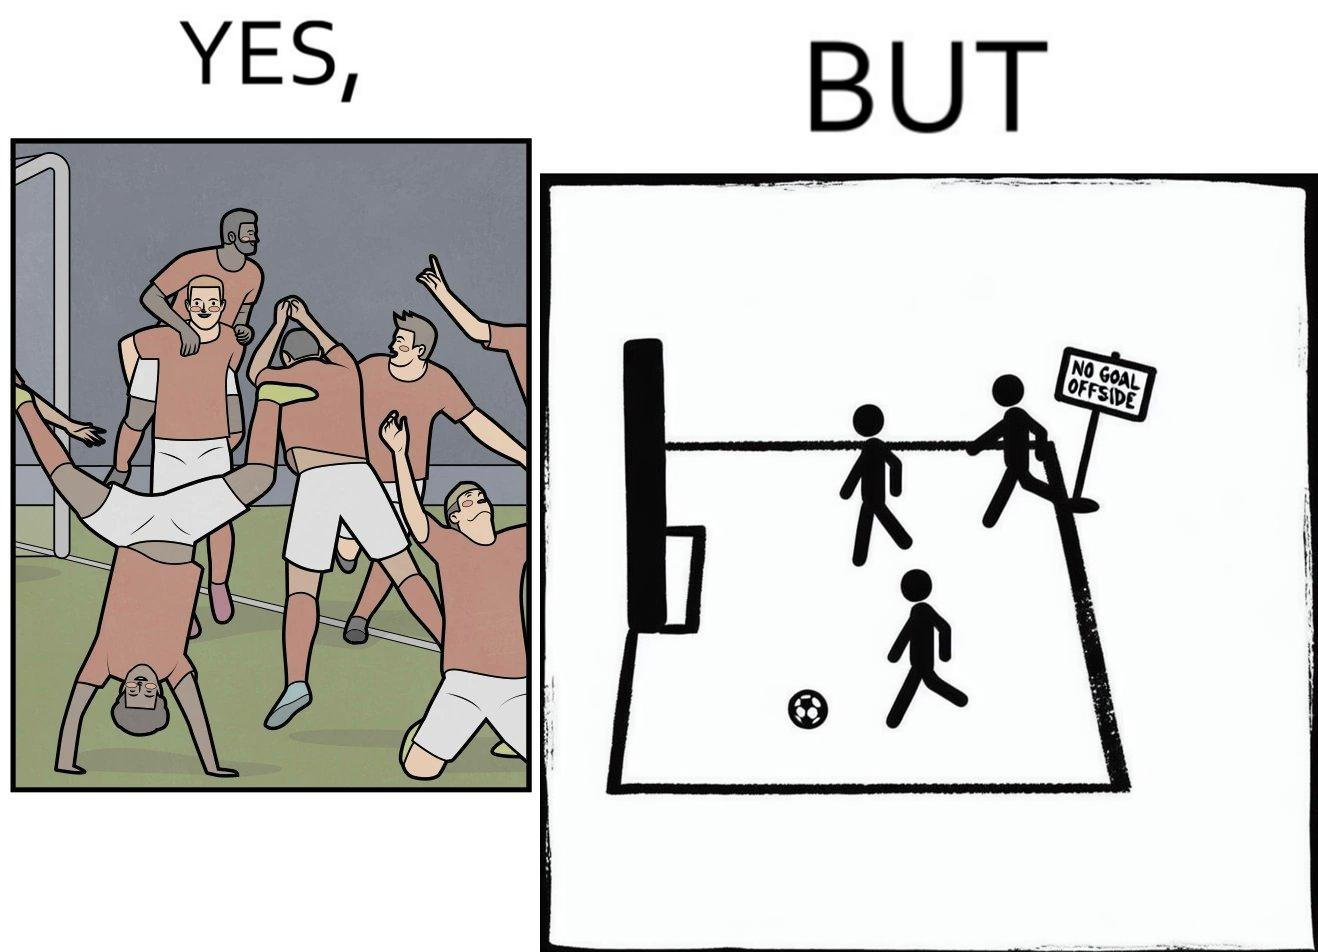What does this image depict? The image is ironical, as the team is celebrating as they think that they have scored a goal, but the sign on the screen says that it is an offside, and not a goal. This is a very common scenario in football matches. 